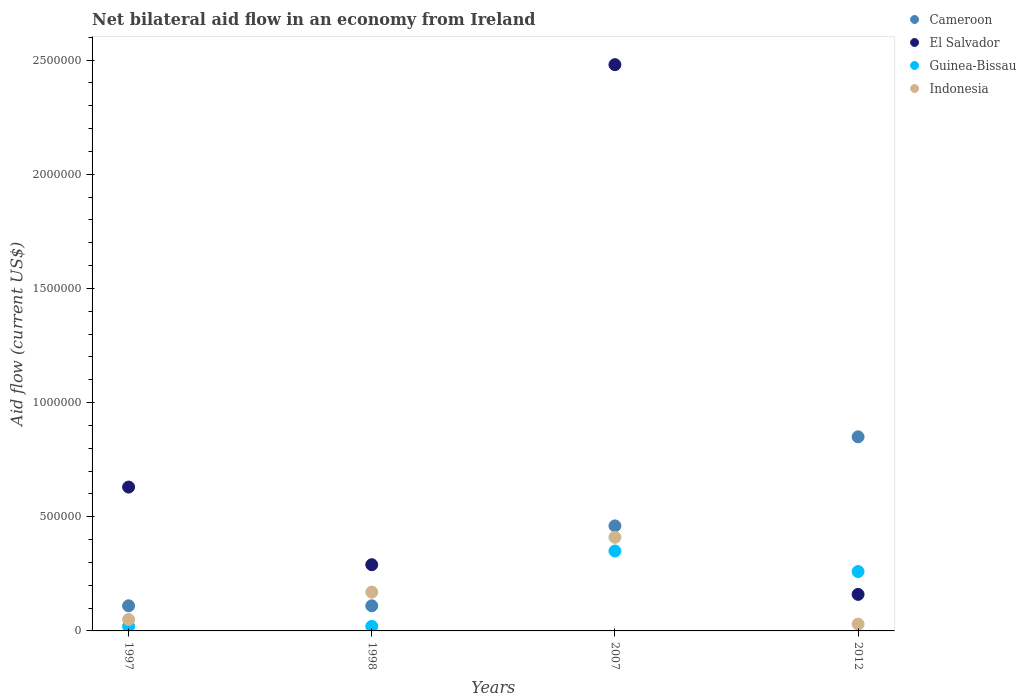Is the number of dotlines equal to the number of legend labels?
Your response must be concise. Yes. What is the net bilateral aid flow in Cameroon in 1997?
Make the answer very short. 1.10e+05. Across all years, what is the maximum net bilateral aid flow in El Salvador?
Provide a succinct answer. 2.48e+06. Across all years, what is the minimum net bilateral aid flow in Cameroon?
Your answer should be very brief. 1.10e+05. What is the total net bilateral aid flow in Indonesia in the graph?
Your answer should be very brief. 6.60e+05. What is the difference between the net bilateral aid flow in Guinea-Bissau in 1998 and the net bilateral aid flow in Indonesia in 1997?
Provide a short and direct response. -3.00e+04. What is the average net bilateral aid flow in Cameroon per year?
Your answer should be compact. 3.82e+05. In the year 2007, what is the difference between the net bilateral aid flow in Indonesia and net bilateral aid flow in El Salvador?
Give a very brief answer. -2.07e+06. In how many years, is the net bilateral aid flow in Indonesia greater than 2400000 US$?
Offer a terse response. 0. What is the ratio of the net bilateral aid flow in Cameroon in 1997 to that in 2012?
Your response must be concise. 0.13. Is the difference between the net bilateral aid flow in Indonesia in 1997 and 1998 greater than the difference between the net bilateral aid flow in El Salvador in 1997 and 1998?
Your answer should be very brief. No. What is the difference between the highest and the second highest net bilateral aid flow in El Salvador?
Provide a short and direct response. 1.85e+06. What is the difference between the highest and the lowest net bilateral aid flow in El Salvador?
Provide a short and direct response. 2.32e+06. Is the sum of the net bilateral aid flow in Indonesia in 1998 and 2012 greater than the maximum net bilateral aid flow in El Salvador across all years?
Your answer should be compact. No. Does the net bilateral aid flow in Indonesia monotonically increase over the years?
Provide a short and direct response. No. Is the net bilateral aid flow in Guinea-Bissau strictly greater than the net bilateral aid flow in Indonesia over the years?
Provide a short and direct response. No. How many years are there in the graph?
Your answer should be very brief. 4. Does the graph contain any zero values?
Keep it short and to the point. No. Where does the legend appear in the graph?
Your answer should be compact. Top right. How are the legend labels stacked?
Give a very brief answer. Vertical. What is the title of the graph?
Keep it short and to the point. Net bilateral aid flow in an economy from Ireland. Does "Curacao" appear as one of the legend labels in the graph?
Your response must be concise. No. What is the label or title of the X-axis?
Make the answer very short. Years. What is the Aid flow (current US$) in Cameroon in 1997?
Make the answer very short. 1.10e+05. What is the Aid flow (current US$) in El Salvador in 1997?
Make the answer very short. 6.30e+05. What is the Aid flow (current US$) of Indonesia in 1997?
Provide a short and direct response. 5.00e+04. What is the Aid flow (current US$) in Cameroon in 1998?
Keep it short and to the point. 1.10e+05. What is the Aid flow (current US$) of El Salvador in 2007?
Your answer should be compact. 2.48e+06. What is the Aid flow (current US$) in Guinea-Bissau in 2007?
Provide a succinct answer. 3.50e+05. What is the Aid flow (current US$) in Indonesia in 2007?
Provide a succinct answer. 4.10e+05. What is the Aid flow (current US$) in Cameroon in 2012?
Your response must be concise. 8.50e+05. What is the Aid flow (current US$) in El Salvador in 2012?
Provide a short and direct response. 1.60e+05. What is the Aid flow (current US$) in Indonesia in 2012?
Ensure brevity in your answer.  3.00e+04. Across all years, what is the maximum Aid flow (current US$) in Cameroon?
Your answer should be very brief. 8.50e+05. Across all years, what is the maximum Aid flow (current US$) of El Salvador?
Offer a very short reply. 2.48e+06. Across all years, what is the maximum Aid flow (current US$) in Guinea-Bissau?
Your answer should be very brief. 3.50e+05. Across all years, what is the maximum Aid flow (current US$) in Indonesia?
Provide a short and direct response. 4.10e+05. Across all years, what is the minimum Aid flow (current US$) in Guinea-Bissau?
Provide a succinct answer. 2.00e+04. Across all years, what is the minimum Aid flow (current US$) in Indonesia?
Your response must be concise. 3.00e+04. What is the total Aid flow (current US$) of Cameroon in the graph?
Your answer should be very brief. 1.53e+06. What is the total Aid flow (current US$) of El Salvador in the graph?
Keep it short and to the point. 3.56e+06. What is the total Aid flow (current US$) of Guinea-Bissau in the graph?
Provide a succinct answer. 6.50e+05. What is the difference between the Aid flow (current US$) of Cameroon in 1997 and that in 1998?
Give a very brief answer. 0. What is the difference between the Aid flow (current US$) in El Salvador in 1997 and that in 1998?
Make the answer very short. 3.40e+05. What is the difference between the Aid flow (current US$) of Cameroon in 1997 and that in 2007?
Provide a succinct answer. -3.50e+05. What is the difference between the Aid flow (current US$) of El Salvador in 1997 and that in 2007?
Your response must be concise. -1.85e+06. What is the difference between the Aid flow (current US$) in Guinea-Bissau in 1997 and that in 2007?
Give a very brief answer. -3.30e+05. What is the difference between the Aid flow (current US$) in Indonesia in 1997 and that in 2007?
Provide a succinct answer. -3.60e+05. What is the difference between the Aid flow (current US$) of Cameroon in 1997 and that in 2012?
Your response must be concise. -7.40e+05. What is the difference between the Aid flow (current US$) in Guinea-Bissau in 1997 and that in 2012?
Provide a succinct answer. -2.40e+05. What is the difference between the Aid flow (current US$) in Indonesia in 1997 and that in 2012?
Provide a short and direct response. 2.00e+04. What is the difference between the Aid flow (current US$) in Cameroon in 1998 and that in 2007?
Provide a succinct answer. -3.50e+05. What is the difference between the Aid flow (current US$) in El Salvador in 1998 and that in 2007?
Keep it short and to the point. -2.19e+06. What is the difference between the Aid flow (current US$) of Guinea-Bissau in 1998 and that in 2007?
Keep it short and to the point. -3.30e+05. What is the difference between the Aid flow (current US$) of Cameroon in 1998 and that in 2012?
Provide a succinct answer. -7.40e+05. What is the difference between the Aid flow (current US$) in El Salvador in 1998 and that in 2012?
Offer a very short reply. 1.30e+05. What is the difference between the Aid flow (current US$) of Indonesia in 1998 and that in 2012?
Keep it short and to the point. 1.40e+05. What is the difference between the Aid flow (current US$) of Cameroon in 2007 and that in 2012?
Offer a very short reply. -3.90e+05. What is the difference between the Aid flow (current US$) in El Salvador in 2007 and that in 2012?
Keep it short and to the point. 2.32e+06. What is the difference between the Aid flow (current US$) in Indonesia in 2007 and that in 2012?
Your response must be concise. 3.80e+05. What is the difference between the Aid flow (current US$) in El Salvador in 1997 and the Aid flow (current US$) in Guinea-Bissau in 1998?
Offer a terse response. 6.10e+05. What is the difference between the Aid flow (current US$) in El Salvador in 1997 and the Aid flow (current US$) in Indonesia in 1998?
Ensure brevity in your answer.  4.60e+05. What is the difference between the Aid flow (current US$) of Cameroon in 1997 and the Aid flow (current US$) of El Salvador in 2007?
Keep it short and to the point. -2.37e+06. What is the difference between the Aid flow (current US$) in Cameroon in 1997 and the Aid flow (current US$) in Guinea-Bissau in 2007?
Provide a succinct answer. -2.40e+05. What is the difference between the Aid flow (current US$) of Guinea-Bissau in 1997 and the Aid flow (current US$) of Indonesia in 2007?
Keep it short and to the point. -3.90e+05. What is the difference between the Aid flow (current US$) in Cameroon in 1997 and the Aid flow (current US$) in El Salvador in 2012?
Make the answer very short. -5.00e+04. What is the difference between the Aid flow (current US$) in Cameroon in 1997 and the Aid flow (current US$) in Guinea-Bissau in 2012?
Give a very brief answer. -1.50e+05. What is the difference between the Aid flow (current US$) of El Salvador in 1997 and the Aid flow (current US$) of Indonesia in 2012?
Provide a succinct answer. 6.00e+05. What is the difference between the Aid flow (current US$) in Guinea-Bissau in 1997 and the Aid flow (current US$) in Indonesia in 2012?
Your answer should be compact. -10000. What is the difference between the Aid flow (current US$) of Cameroon in 1998 and the Aid flow (current US$) of El Salvador in 2007?
Offer a terse response. -2.37e+06. What is the difference between the Aid flow (current US$) in Guinea-Bissau in 1998 and the Aid flow (current US$) in Indonesia in 2007?
Your answer should be compact. -3.90e+05. What is the difference between the Aid flow (current US$) of Cameroon in 1998 and the Aid flow (current US$) of El Salvador in 2012?
Make the answer very short. -5.00e+04. What is the difference between the Aid flow (current US$) in Cameroon in 1998 and the Aid flow (current US$) in Indonesia in 2012?
Keep it short and to the point. 8.00e+04. What is the difference between the Aid flow (current US$) in El Salvador in 1998 and the Aid flow (current US$) in Indonesia in 2012?
Offer a very short reply. 2.60e+05. What is the difference between the Aid flow (current US$) of Cameroon in 2007 and the Aid flow (current US$) of El Salvador in 2012?
Provide a short and direct response. 3.00e+05. What is the difference between the Aid flow (current US$) in Cameroon in 2007 and the Aid flow (current US$) in Indonesia in 2012?
Keep it short and to the point. 4.30e+05. What is the difference between the Aid flow (current US$) in El Salvador in 2007 and the Aid flow (current US$) in Guinea-Bissau in 2012?
Your response must be concise. 2.22e+06. What is the difference between the Aid flow (current US$) of El Salvador in 2007 and the Aid flow (current US$) of Indonesia in 2012?
Ensure brevity in your answer.  2.45e+06. What is the average Aid flow (current US$) in Cameroon per year?
Keep it short and to the point. 3.82e+05. What is the average Aid flow (current US$) of El Salvador per year?
Offer a very short reply. 8.90e+05. What is the average Aid flow (current US$) of Guinea-Bissau per year?
Make the answer very short. 1.62e+05. What is the average Aid flow (current US$) in Indonesia per year?
Make the answer very short. 1.65e+05. In the year 1997, what is the difference between the Aid flow (current US$) of Cameroon and Aid flow (current US$) of El Salvador?
Provide a short and direct response. -5.20e+05. In the year 1997, what is the difference between the Aid flow (current US$) in Cameroon and Aid flow (current US$) in Guinea-Bissau?
Make the answer very short. 9.00e+04. In the year 1997, what is the difference between the Aid flow (current US$) of El Salvador and Aid flow (current US$) of Guinea-Bissau?
Your answer should be compact. 6.10e+05. In the year 1997, what is the difference between the Aid flow (current US$) in El Salvador and Aid flow (current US$) in Indonesia?
Provide a short and direct response. 5.80e+05. In the year 1997, what is the difference between the Aid flow (current US$) of Guinea-Bissau and Aid flow (current US$) of Indonesia?
Ensure brevity in your answer.  -3.00e+04. In the year 2007, what is the difference between the Aid flow (current US$) in Cameroon and Aid flow (current US$) in El Salvador?
Make the answer very short. -2.02e+06. In the year 2007, what is the difference between the Aid flow (current US$) of Cameroon and Aid flow (current US$) of Guinea-Bissau?
Your response must be concise. 1.10e+05. In the year 2007, what is the difference between the Aid flow (current US$) in Cameroon and Aid flow (current US$) in Indonesia?
Provide a short and direct response. 5.00e+04. In the year 2007, what is the difference between the Aid flow (current US$) of El Salvador and Aid flow (current US$) of Guinea-Bissau?
Provide a short and direct response. 2.13e+06. In the year 2007, what is the difference between the Aid flow (current US$) in El Salvador and Aid flow (current US$) in Indonesia?
Your answer should be compact. 2.07e+06. In the year 2012, what is the difference between the Aid flow (current US$) in Cameroon and Aid flow (current US$) in El Salvador?
Your response must be concise. 6.90e+05. In the year 2012, what is the difference between the Aid flow (current US$) in Cameroon and Aid flow (current US$) in Guinea-Bissau?
Ensure brevity in your answer.  5.90e+05. In the year 2012, what is the difference between the Aid flow (current US$) of Cameroon and Aid flow (current US$) of Indonesia?
Give a very brief answer. 8.20e+05. In the year 2012, what is the difference between the Aid flow (current US$) in El Salvador and Aid flow (current US$) in Indonesia?
Offer a very short reply. 1.30e+05. In the year 2012, what is the difference between the Aid flow (current US$) in Guinea-Bissau and Aid flow (current US$) in Indonesia?
Offer a very short reply. 2.30e+05. What is the ratio of the Aid flow (current US$) of El Salvador in 1997 to that in 1998?
Ensure brevity in your answer.  2.17. What is the ratio of the Aid flow (current US$) of Indonesia in 1997 to that in 1998?
Give a very brief answer. 0.29. What is the ratio of the Aid flow (current US$) of Cameroon in 1997 to that in 2007?
Offer a very short reply. 0.24. What is the ratio of the Aid flow (current US$) of El Salvador in 1997 to that in 2007?
Ensure brevity in your answer.  0.25. What is the ratio of the Aid flow (current US$) of Guinea-Bissau in 1997 to that in 2007?
Your response must be concise. 0.06. What is the ratio of the Aid flow (current US$) of Indonesia in 1997 to that in 2007?
Make the answer very short. 0.12. What is the ratio of the Aid flow (current US$) in Cameroon in 1997 to that in 2012?
Your answer should be compact. 0.13. What is the ratio of the Aid flow (current US$) in El Salvador in 1997 to that in 2012?
Your response must be concise. 3.94. What is the ratio of the Aid flow (current US$) in Guinea-Bissau in 1997 to that in 2012?
Ensure brevity in your answer.  0.08. What is the ratio of the Aid flow (current US$) of Cameroon in 1998 to that in 2007?
Give a very brief answer. 0.24. What is the ratio of the Aid flow (current US$) in El Salvador in 1998 to that in 2007?
Offer a very short reply. 0.12. What is the ratio of the Aid flow (current US$) in Guinea-Bissau in 1998 to that in 2007?
Provide a succinct answer. 0.06. What is the ratio of the Aid flow (current US$) of Indonesia in 1998 to that in 2007?
Ensure brevity in your answer.  0.41. What is the ratio of the Aid flow (current US$) in Cameroon in 1998 to that in 2012?
Your response must be concise. 0.13. What is the ratio of the Aid flow (current US$) in El Salvador in 1998 to that in 2012?
Your answer should be very brief. 1.81. What is the ratio of the Aid flow (current US$) of Guinea-Bissau in 1998 to that in 2012?
Provide a succinct answer. 0.08. What is the ratio of the Aid flow (current US$) of Indonesia in 1998 to that in 2012?
Give a very brief answer. 5.67. What is the ratio of the Aid flow (current US$) in Cameroon in 2007 to that in 2012?
Your answer should be compact. 0.54. What is the ratio of the Aid flow (current US$) in Guinea-Bissau in 2007 to that in 2012?
Provide a short and direct response. 1.35. What is the ratio of the Aid flow (current US$) of Indonesia in 2007 to that in 2012?
Your response must be concise. 13.67. What is the difference between the highest and the second highest Aid flow (current US$) in El Salvador?
Give a very brief answer. 1.85e+06. What is the difference between the highest and the second highest Aid flow (current US$) in Guinea-Bissau?
Provide a short and direct response. 9.00e+04. What is the difference between the highest and the lowest Aid flow (current US$) in Cameroon?
Provide a succinct answer. 7.40e+05. What is the difference between the highest and the lowest Aid flow (current US$) in El Salvador?
Your response must be concise. 2.32e+06. What is the difference between the highest and the lowest Aid flow (current US$) of Indonesia?
Provide a succinct answer. 3.80e+05. 